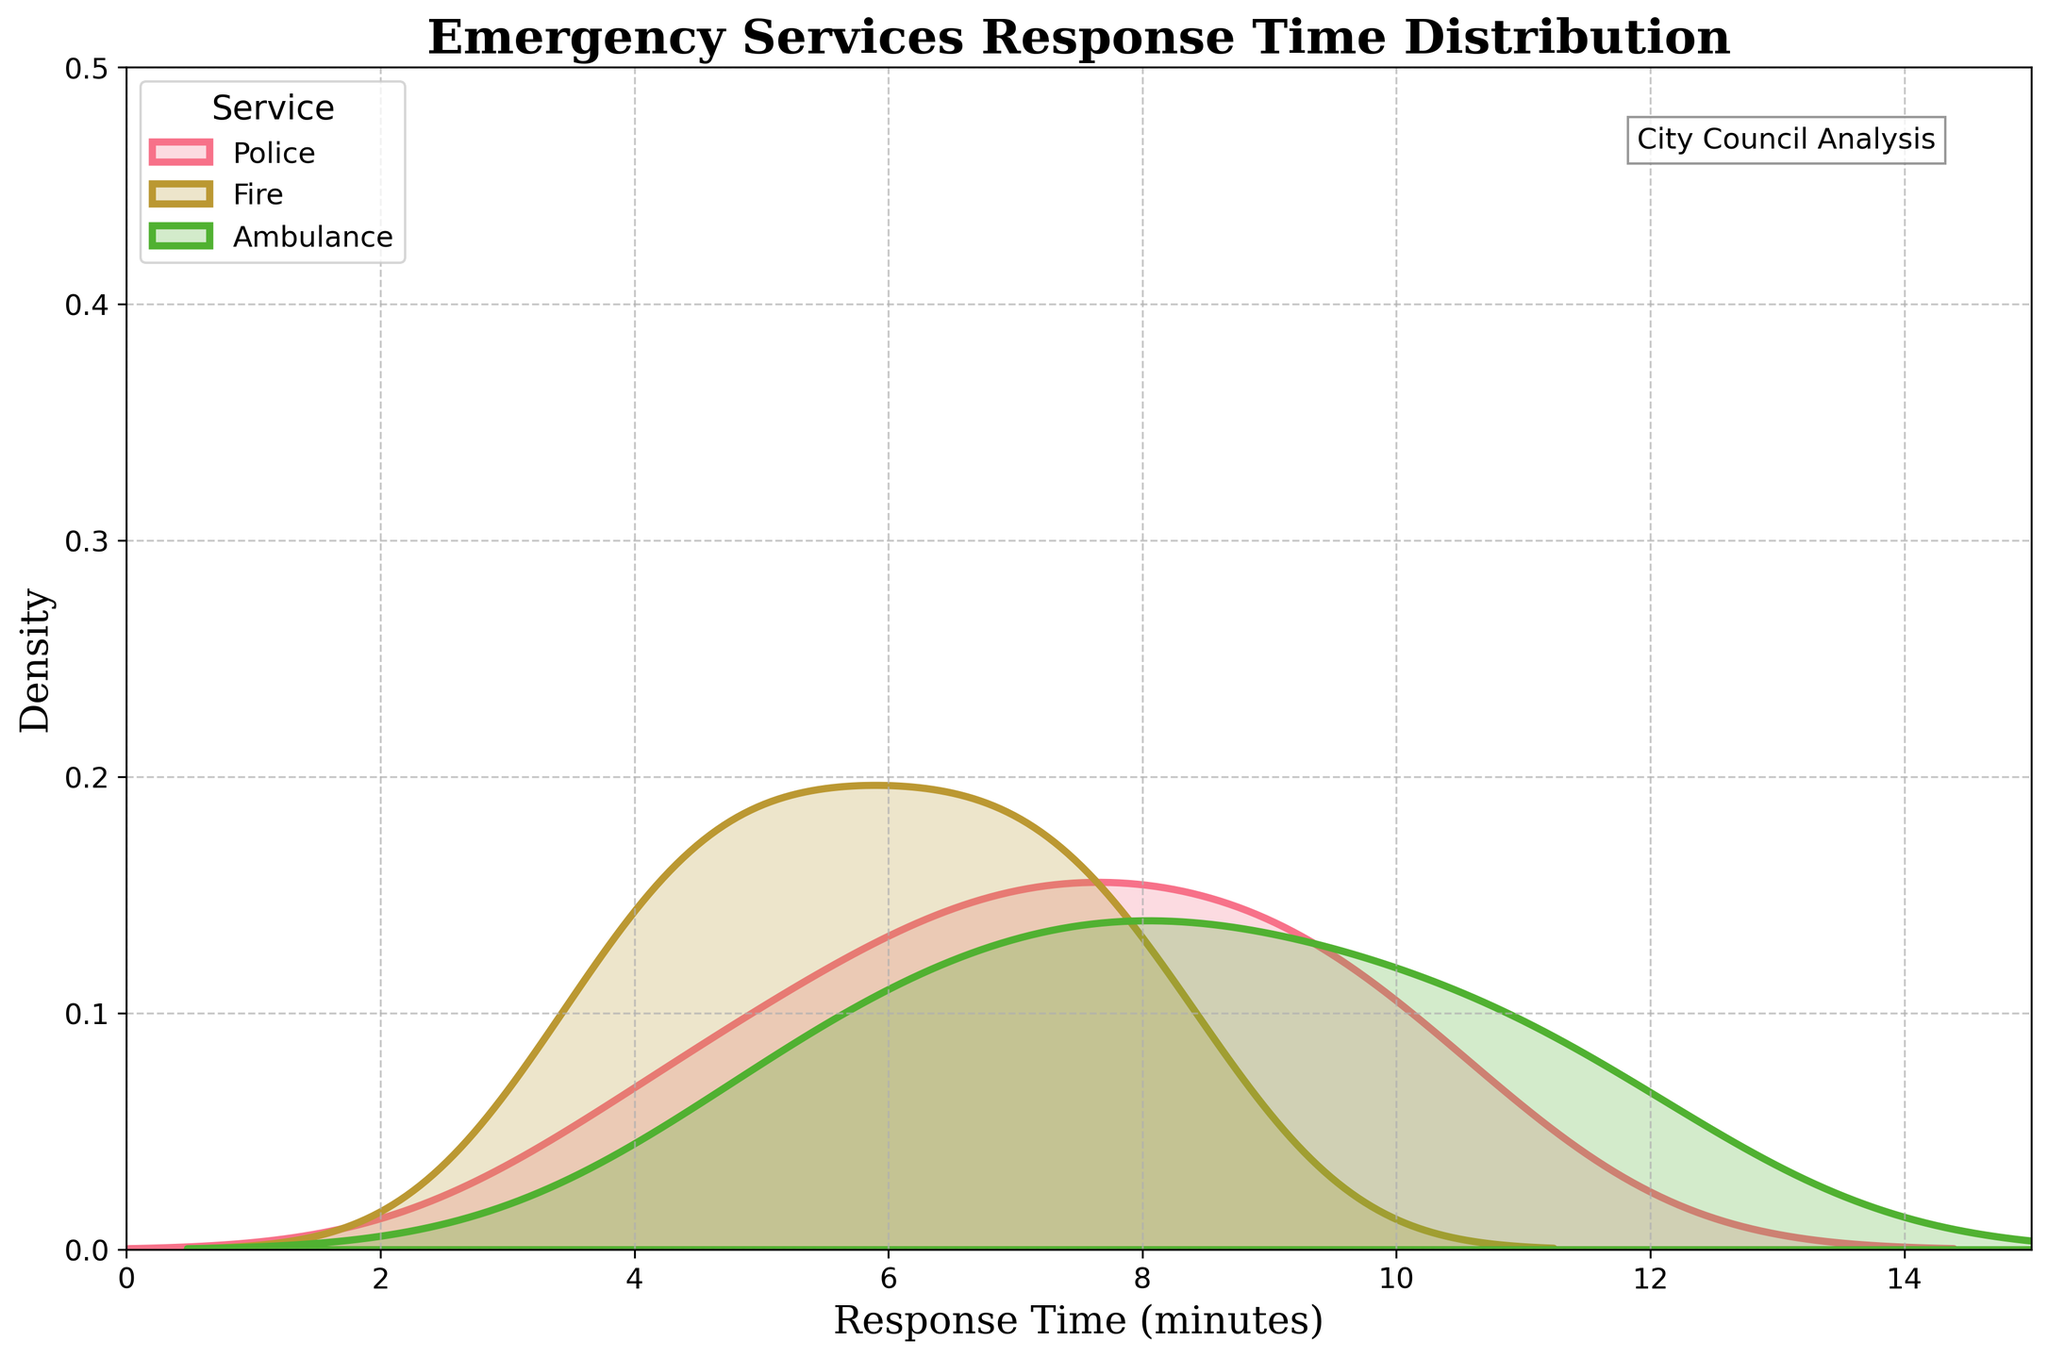What is the title of the plotted figure? The title is displayed at the top of the plot in large, bold font.
Answer: Emergency Services Response Time Distribution What does the x-axis represent? The x-axis label appears at the bottom of the plot. It indicates what is being measured horizontally.
Answer: Response Time (minutes) Which emergency service has the highest peak density? Identify the highest peak in the density plot and see which service it corresponds to.
Answer: Fire Where is the legend located and what does it represent? The legend is located inside the plot area and provides information on each density line color and the corresponding service.
Answer: It describes the services: Police, Fire, Ambulance Which district has the longest average response time across all services? By examining the plot, the longer response times tend to congregate more to the right side of the plot.
Answer: Industrial Park What is the general trend observed for police response times compared to other services? Look at the overall shape and placement of the density plot for police compared to fire and ambulance.
Answer: Police have longer response times on average Comparing the peak densities, which service appears to have the fastest response time? Identify which density plot has its peak (maximum) further to the left on the x-axis.
Answer: Fire What is the approximate response time at which the density plot for Fire services has its peak? Locate the highest point on the density plot for Fire and read the corresponding response time on the x-axis.
Answer: Around 5 minutes How does the ambulance service's response time density compare to that of the police? Compare the density distribution of the ambulance and police lines across the x-axis.
Answer: Ambulance tends to have longer response times than police Is there a significant overlap in response times among the three emergency services? Observe where the density plots of the services overlap; significant overlaps indicate similar response times.
Answer: Yes, there is an overlap, especially around the 5 to 7-minute range 